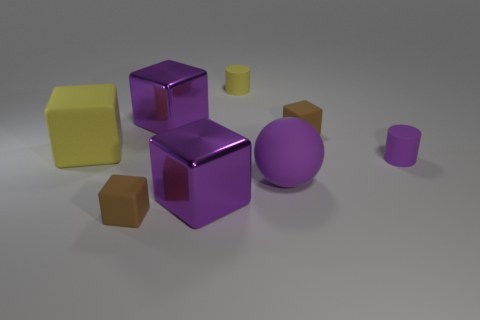How many things are either yellow blocks or small purple matte things?
Give a very brief answer. 2. How many other things are the same color as the sphere?
Give a very brief answer. 3. What is the shape of the yellow thing that is the same size as the purple rubber cylinder?
Offer a very short reply. Cylinder. The tiny rubber block behind the small purple matte cylinder is what color?
Your answer should be compact. Brown. How many things are either tiny matte things left of the tiny purple object or large purple cubes in front of the purple rubber cylinder?
Offer a terse response. 4. Do the yellow block and the purple sphere have the same size?
Give a very brief answer. Yes. How many cylinders are big purple things or small matte objects?
Offer a terse response. 2. What number of rubber things are in front of the tiny yellow matte thing and on the right side of the big yellow rubber cube?
Your answer should be compact. 4. Does the rubber sphere have the same size as the purple object that is to the right of the big ball?
Offer a very short reply. No. There is a big yellow rubber block to the left of the brown block that is on the left side of the large purple rubber ball; are there any matte spheres behind it?
Your response must be concise. No. 